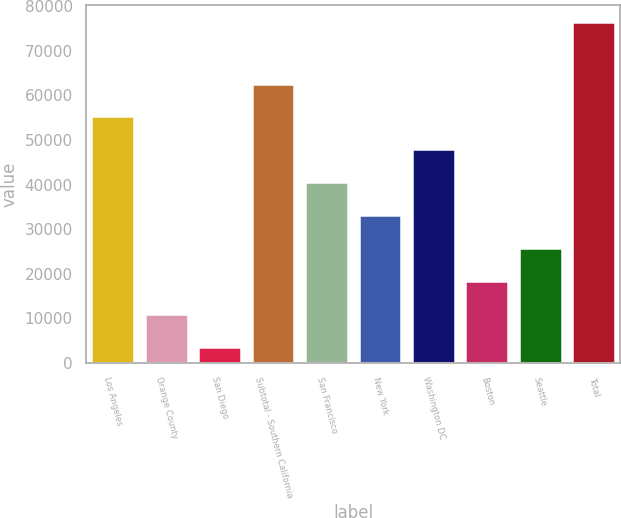<chart> <loc_0><loc_0><loc_500><loc_500><bar_chart><fcel>Los Angeles<fcel>Orange County<fcel>San Diego<fcel>Subtotal - Southern California<fcel>San Francisco<fcel>New York<fcel>Washington DC<fcel>Boston<fcel>Seattle<fcel>Total<nl><fcel>55272.1<fcel>10900.3<fcel>3505<fcel>62667.4<fcel>40481.5<fcel>33086.2<fcel>47876.8<fcel>18295.6<fcel>25690.9<fcel>76513<nl></chart> 